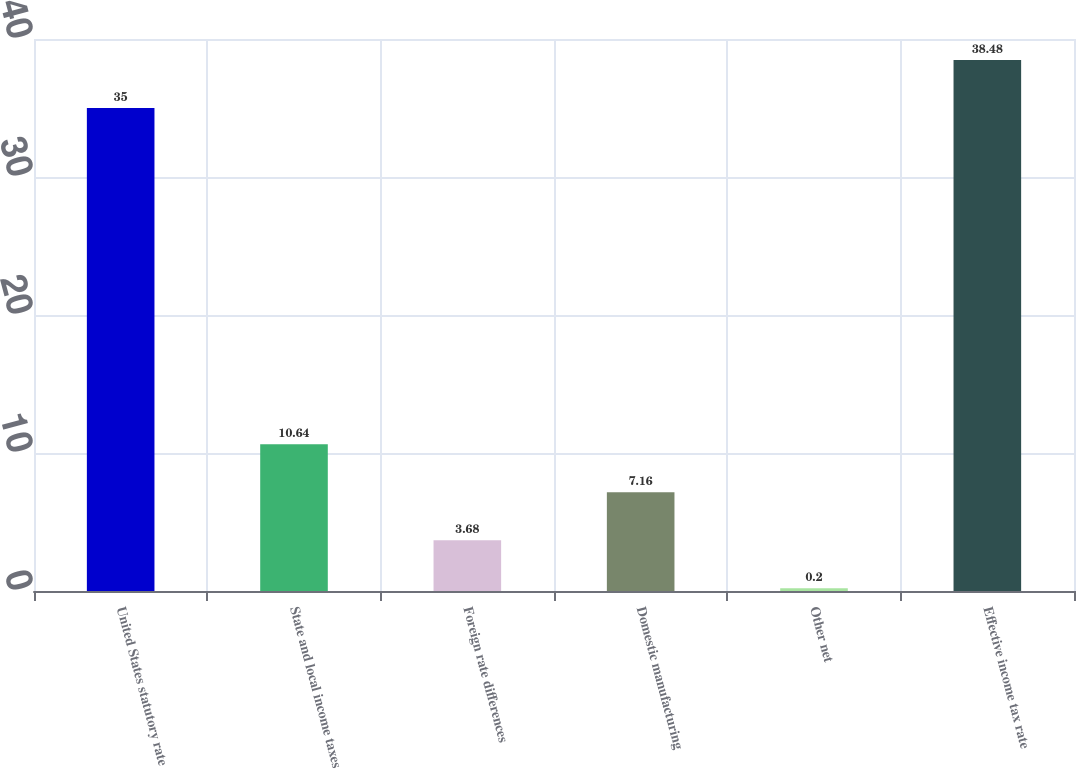Convert chart to OTSL. <chart><loc_0><loc_0><loc_500><loc_500><bar_chart><fcel>United States statutory rate<fcel>State and local income taxes<fcel>Foreign rate differences<fcel>Domestic manufacturing<fcel>Other net<fcel>Effective income tax rate<nl><fcel>35<fcel>10.64<fcel>3.68<fcel>7.16<fcel>0.2<fcel>38.48<nl></chart> 